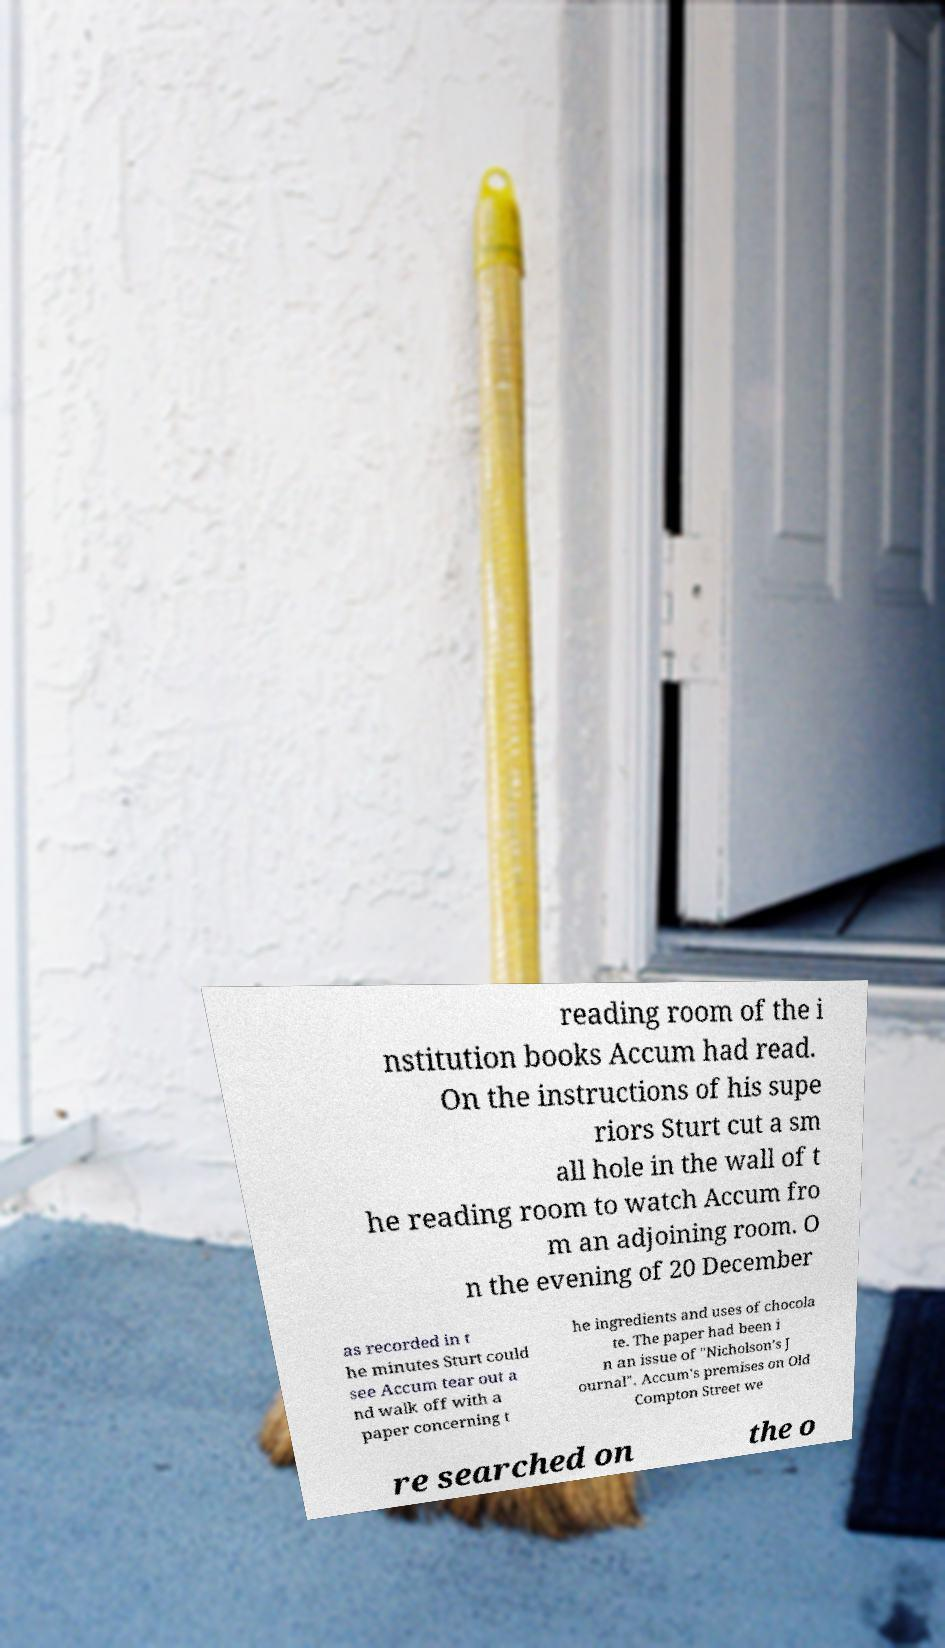Please read and relay the text visible in this image. What does it say? reading room of the i nstitution books Accum had read. On the instructions of his supe riors Sturt cut a sm all hole in the wall of t he reading room to watch Accum fro m an adjoining room. O n the evening of 20 December as recorded in t he minutes Sturt could see Accum tear out a nd walk off with a paper concerning t he ingredients and uses of chocola te. The paper had been i n an issue of "Nicholson’s J ournal". Accum's premises on Old Compton Street we re searched on the o 